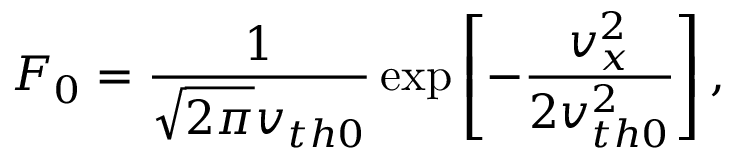Convert formula to latex. <formula><loc_0><loc_0><loc_500><loc_500>F _ { 0 } = \frac { 1 } { \sqrt { 2 \pi } v _ { t h 0 } } \exp \left [ - \frac { v _ { x } ^ { 2 } } { 2 v _ { t h 0 } ^ { 2 } } \right ] ,</formula> 